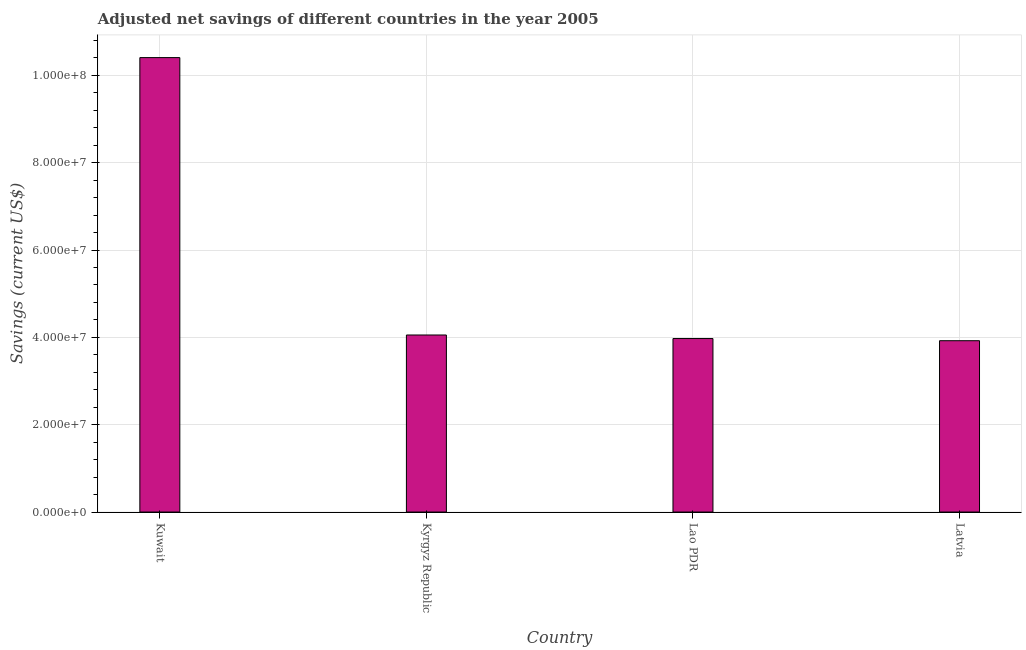Does the graph contain any zero values?
Your response must be concise. No. Does the graph contain grids?
Offer a terse response. Yes. What is the title of the graph?
Provide a succinct answer. Adjusted net savings of different countries in the year 2005. What is the label or title of the Y-axis?
Keep it short and to the point. Savings (current US$). What is the adjusted net savings in Kuwait?
Provide a short and direct response. 1.04e+08. Across all countries, what is the maximum adjusted net savings?
Offer a very short reply. 1.04e+08. Across all countries, what is the minimum adjusted net savings?
Your answer should be very brief. 3.92e+07. In which country was the adjusted net savings maximum?
Offer a terse response. Kuwait. In which country was the adjusted net savings minimum?
Provide a short and direct response. Latvia. What is the sum of the adjusted net savings?
Provide a short and direct response. 2.24e+08. What is the difference between the adjusted net savings in Kuwait and Kyrgyz Republic?
Offer a terse response. 6.35e+07. What is the average adjusted net savings per country?
Your answer should be compact. 5.59e+07. What is the median adjusted net savings?
Ensure brevity in your answer.  4.01e+07. Is the adjusted net savings in Kuwait less than that in Latvia?
Offer a very short reply. No. Is the difference between the adjusted net savings in Lao PDR and Latvia greater than the difference between any two countries?
Make the answer very short. No. What is the difference between the highest and the second highest adjusted net savings?
Your response must be concise. 6.35e+07. What is the difference between the highest and the lowest adjusted net savings?
Keep it short and to the point. 6.48e+07. In how many countries, is the adjusted net savings greater than the average adjusted net savings taken over all countries?
Your answer should be very brief. 1. Are all the bars in the graph horizontal?
Keep it short and to the point. No. What is the difference between two consecutive major ticks on the Y-axis?
Keep it short and to the point. 2.00e+07. What is the Savings (current US$) in Kuwait?
Make the answer very short. 1.04e+08. What is the Savings (current US$) in Kyrgyz Republic?
Your answer should be very brief. 4.05e+07. What is the Savings (current US$) of Lao PDR?
Give a very brief answer. 3.97e+07. What is the Savings (current US$) in Latvia?
Your answer should be very brief. 3.92e+07. What is the difference between the Savings (current US$) in Kuwait and Kyrgyz Republic?
Your answer should be compact. 6.35e+07. What is the difference between the Savings (current US$) in Kuwait and Lao PDR?
Your response must be concise. 6.43e+07. What is the difference between the Savings (current US$) in Kuwait and Latvia?
Give a very brief answer. 6.48e+07. What is the difference between the Savings (current US$) in Kyrgyz Republic and Lao PDR?
Provide a succinct answer. 8.11e+05. What is the difference between the Savings (current US$) in Kyrgyz Republic and Latvia?
Give a very brief answer. 1.31e+06. What is the difference between the Savings (current US$) in Lao PDR and Latvia?
Give a very brief answer. 4.96e+05. What is the ratio of the Savings (current US$) in Kuwait to that in Kyrgyz Republic?
Make the answer very short. 2.57. What is the ratio of the Savings (current US$) in Kuwait to that in Lao PDR?
Give a very brief answer. 2.62. What is the ratio of the Savings (current US$) in Kuwait to that in Latvia?
Your answer should be compact. 2.65. What is the ratio of the Savings (current US$) in Kyrgyz Republic to that in Lao PDR?
Give a very brief answer. 1.02. What is the ratio of the Savings (current US$) in Kyrgyz Republic to that in Latvia?
Your answer should be compact. 1.03. 